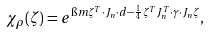<formula> <loc_0><loc_0><loc_500><loc_500>\chi _ { \rho } ( \zeta ) = e ^ { \i m \zeta ^ { T } \cdot J _ { n } \cdot d - \frac { 1 } { 4 } \zeta ^ { T } J ^ { T } _ { n } \cdot \gamma \cdot J _ { n } \zeta } ,</formula> 